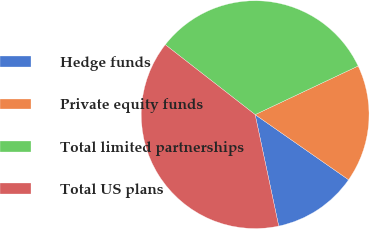Convert chart to OTSL. <chart><loc_0><loc_0><loc_500><loc_500><pie_chart><fcel>Hedge funds<fcel>Private equity funds<fcel>Total limited partnerships<fcel>Total US plans<nl><fcel>11.99%<fcel>16.71%<fcel>32.45%<fcel>38.84%<nl></chart> 